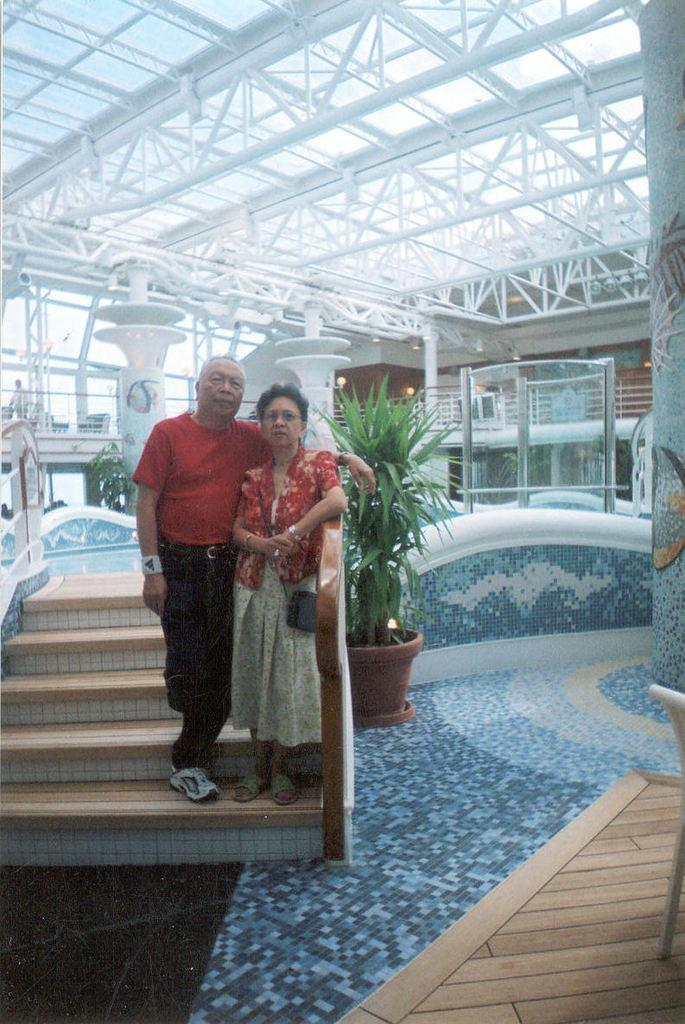Who are the people in the image? There is a man and a woman in the image. Where are the people located in the image? They are on the stairs. What else can be seen in the image besides the people? There is a plant pot in the image. What is visible at the top of the image? There is a roof visible at the top side of the image. What type of oatmeal is being served in the image? There is no oatmeal present in the image. How is the wax being used in the image? There is no wax present in the image. 